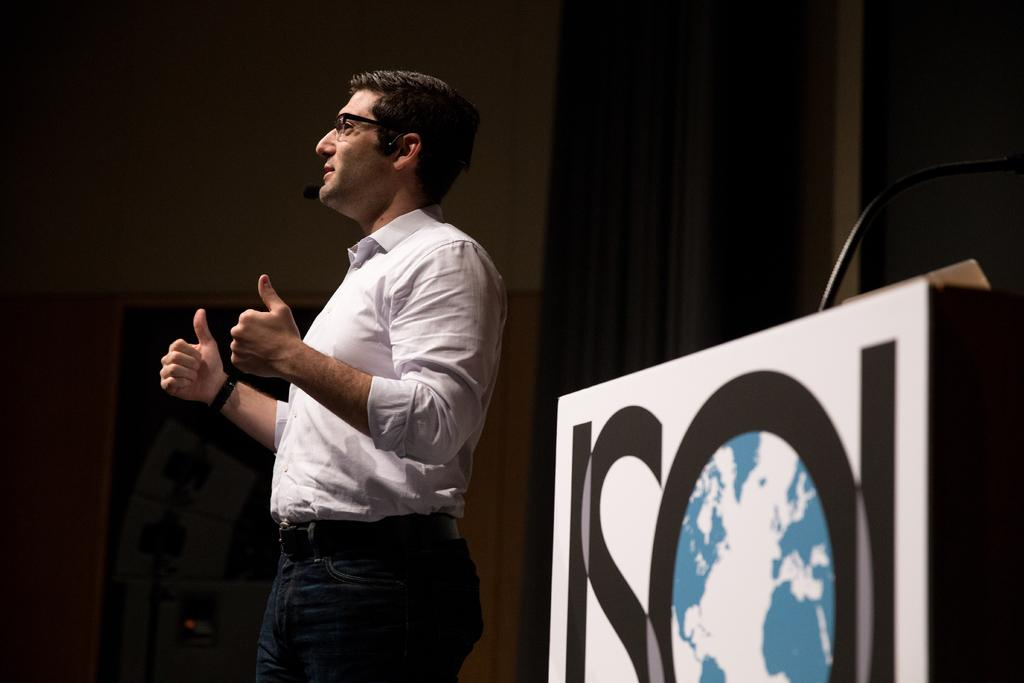Who is in the image? There is a man in the image. What object is in front of the man? There is a podium in the image. Where is the microphone located in the image? A microphone is present on the right side of the image. What can be seen in the background of the image? There is a curtain and a wall in the background of the image. What type of bread is being smoked in the image? There is no bread or smoking activity present in the image. 